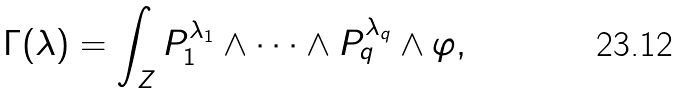<formula> <loc_0><loc_0><loc_500><loc_500>\Gamma ( \lambda ) = \int _ { Z } P _ { 1 } ^ { \lambda _ { 1 } } \wedge \cdots \wedge P _ { q } ^ { \lambda _ { q } } \wedge \varphi ,</formula> 